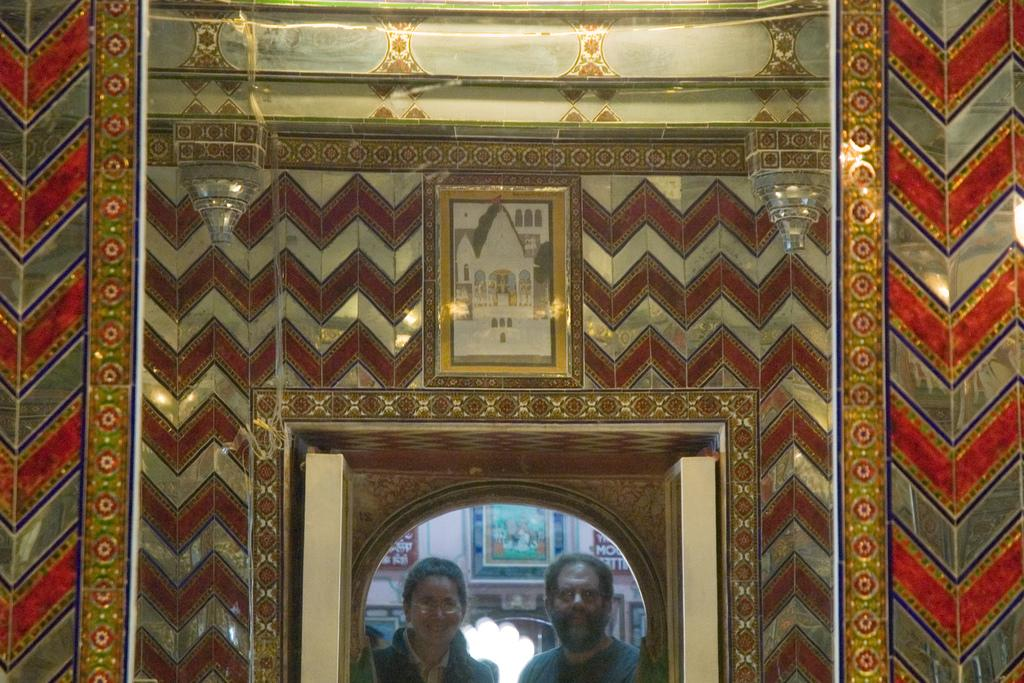What is the main object in the middle of the image? There is a mirror in the middle of the image. What does the mirror show in the image? The mirror reflects two persons in the image. How are the walls in the image decorated? The walls in the image are decorated. What type of rule is being enforced by the wrist in the image? There is no wrist or rule present in the image. What kind of treatment is being administered to the mirror in the image? There is no treatment being administered to the mirror in the image; it is simply reflecting two persons. 